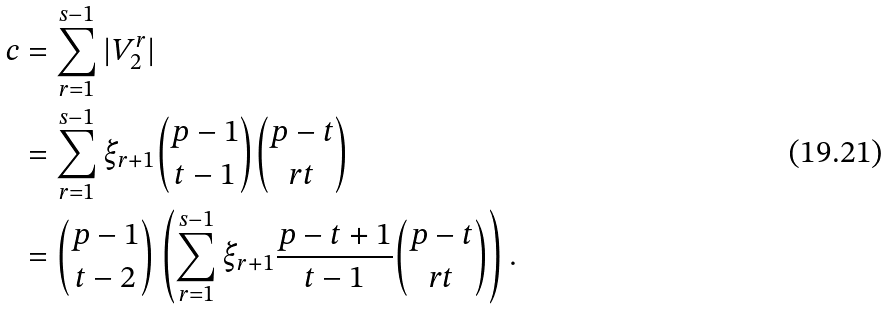Convert formula to latex. <formula><loc_0><loc_0><loc_500><loc_500>c & = \sum _ { r = 1 } ^ { s - 1 } | V _ { 2 } ^ { r } | \\ & = \sum _ { r = 1 } ^ { s - 1 } \xi _ { r + 1 } \binom { p - 1 } { t - 1 } \binom { p - t } { r t } \\ & = \binom { p - 1 } { t - 2 } \left ( \sum _ { r = 1 } ^ { s - 1 } \xi _ { r + 1 } \frac { p - t + 1 } { t - 1 } \binom { p - t } { r t } \right ) .</formula> 